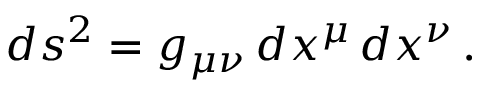<formula> <loc_0><loc_0><loc_500><loc_500>d s ^ { 2 } = g _ { \mu \nu } \, d x ^ { \mu } \, d x ^ { \nu } \, .</formula> 